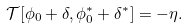Convert formula to latex. <formula><loc_0><loc_0><loc_500><loc_500>\mathcal { T } [ \phi _ { 0 } + \delta , \phi ^ { \ast } _ { 0 } + \delta ^ { \ast } ] = - \eta .</formula> 